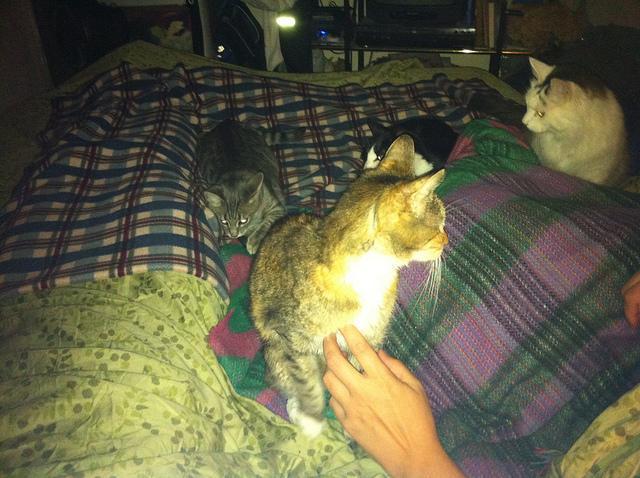How many cats are on the bed?
Give a very brief answer. 4. How many cats are in the photo?
Give a very brief answer. 4. 